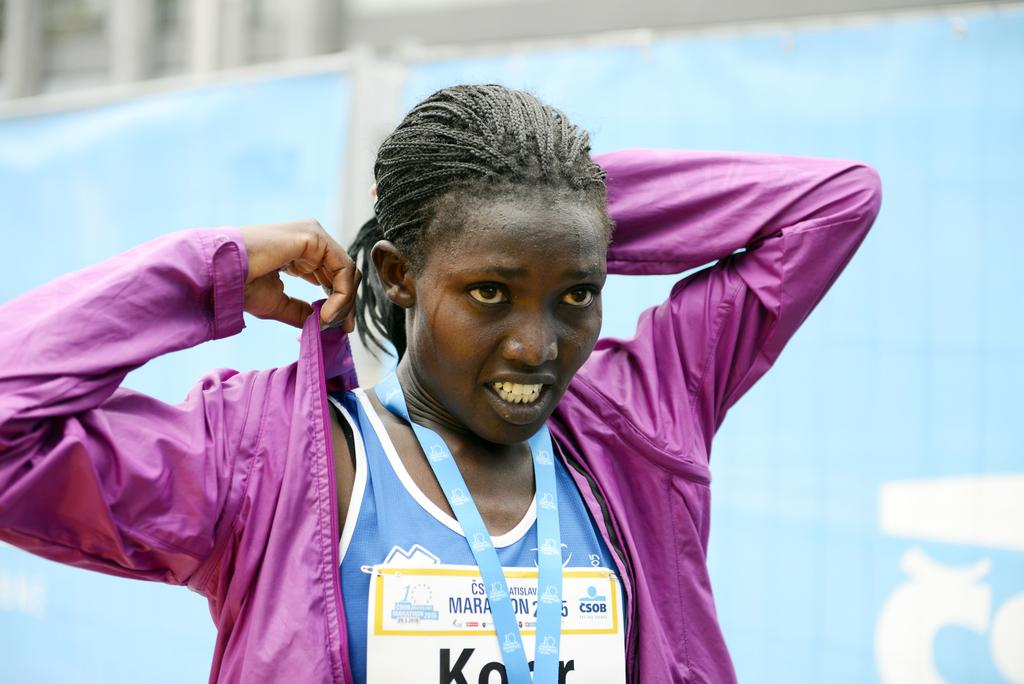Who is present in the image? There is a woman in the image. What is the woman wearing? The woman is wearing a pink jacket. What can be seen in the background of the image? There is a banner and a building in the background of the image. How many sheep are visible in the image? There are no sheep present in the image. What type of spy equipment can be seen in the woman's possession in the image? There is no spy equipment visible in the image, and the woman is not depicted as a spy. 